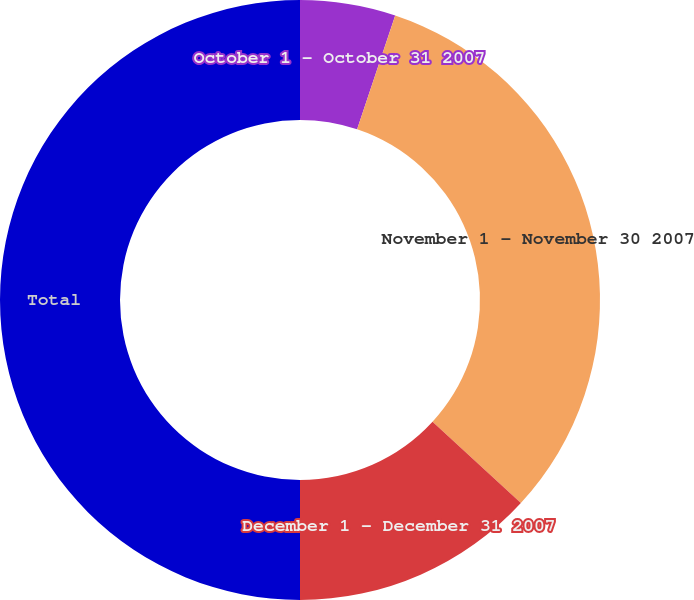<chart> <loc_0><loc_0><loc_500><loc_500><pie_chart><fcel>October 1 - October 31 2007<fcel>November 1 - November 30 2007<fcel>December 1 - December 31 2007<fcel>Total<nl><fcel>5.14%<fcel>31.69%<fcel>13.17%<fcel>50.0%<nl></chart> 